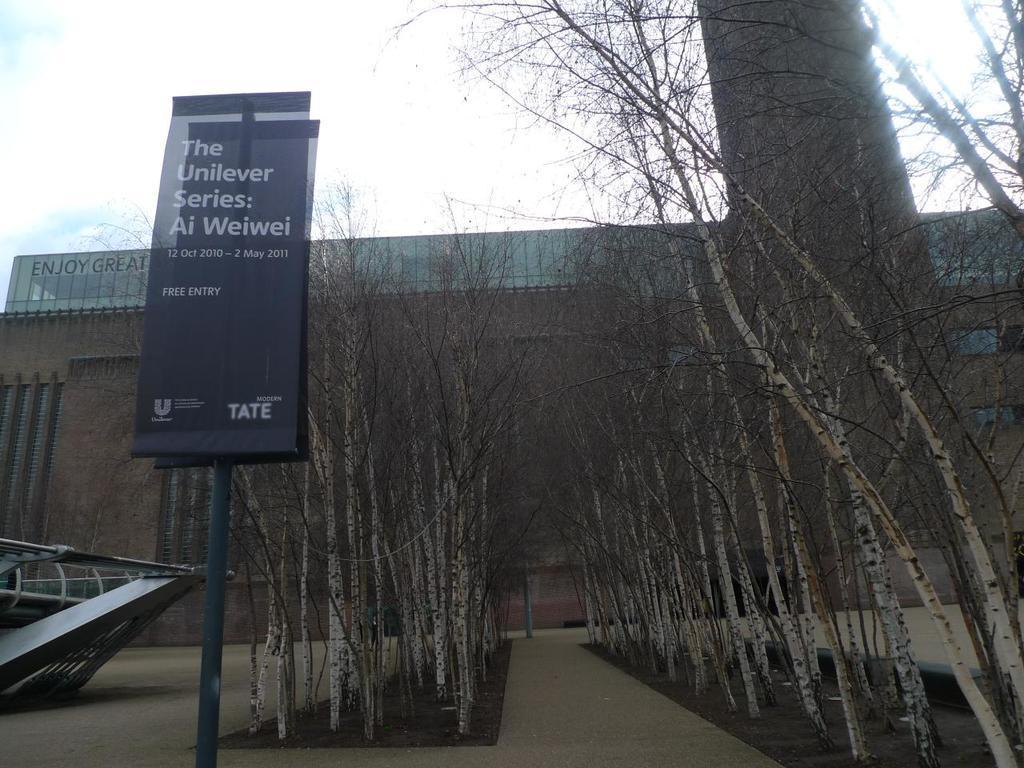In one or two sentences, can you explain what this image depicts? In this image we can see board to the pole, trees, building and the sky with clouds in the background. 